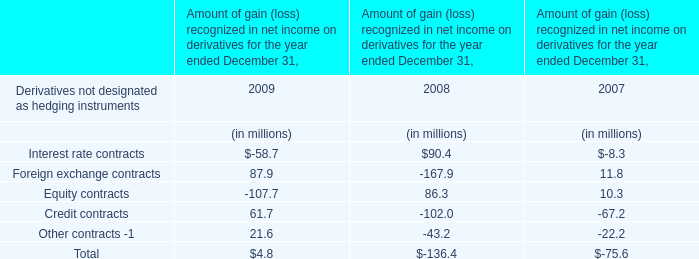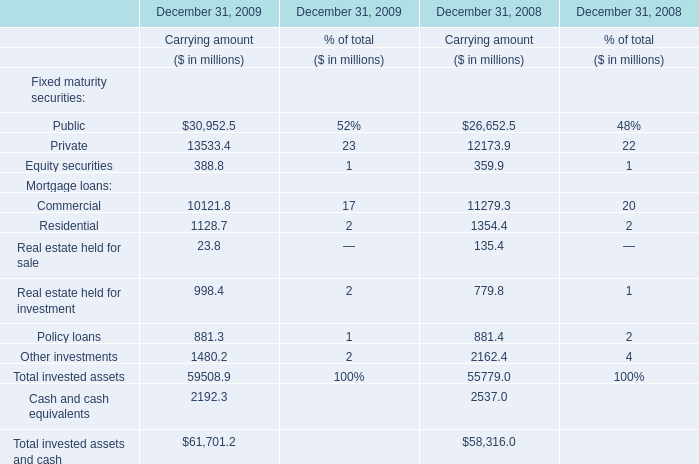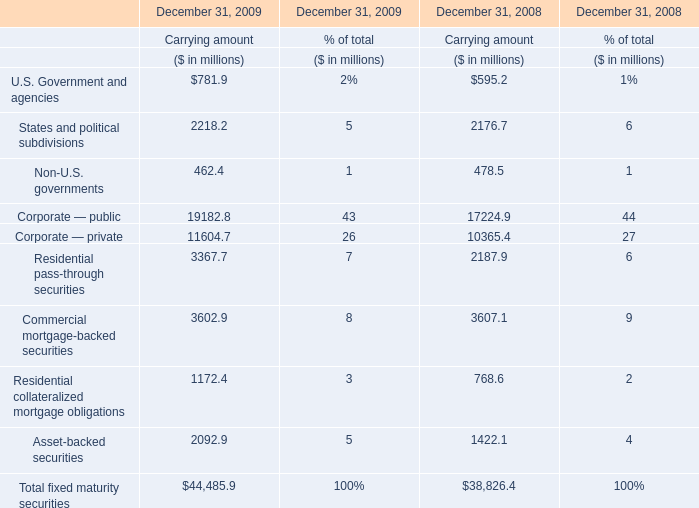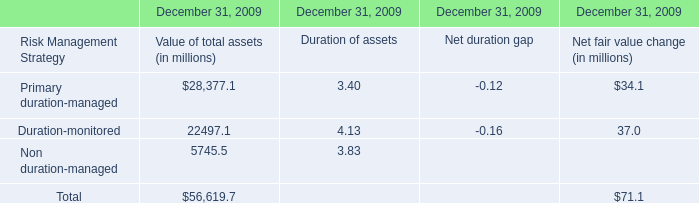When is Fixed maturity securities of public the largest? 
Answer: 2009. 